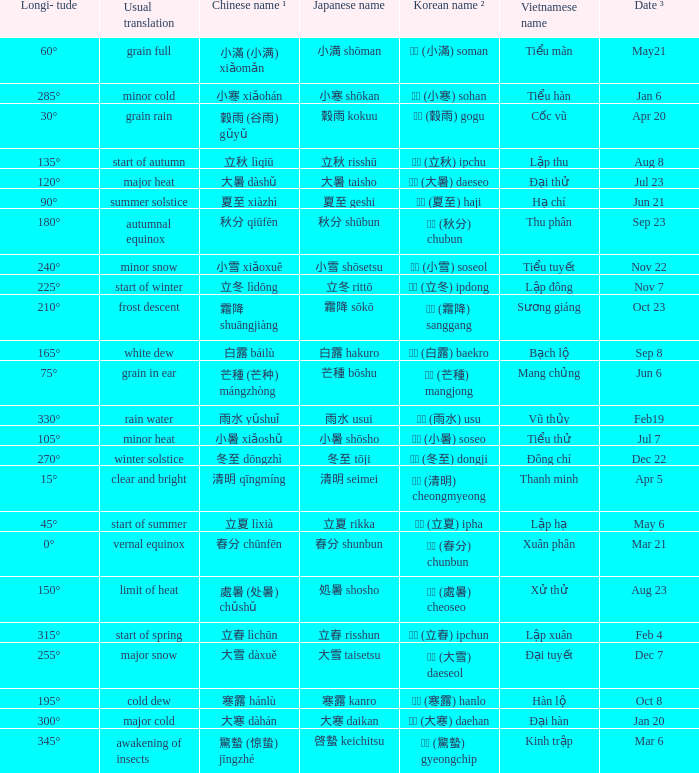WHICH Vietnamese name has a Chinese name ¹ of 芒種 (芒种) mángzhòng? Mang chủng. 